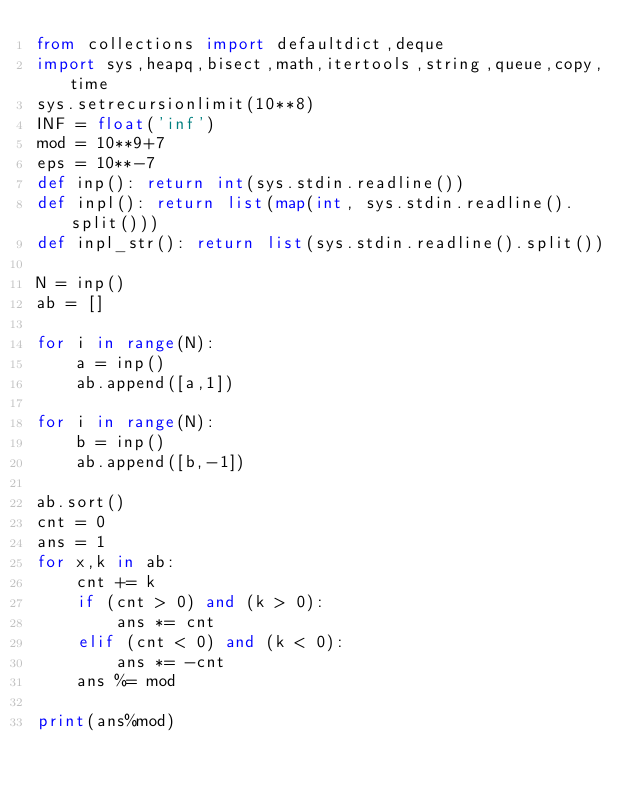Convert code to text. <code><loc_0><loc_0><loc_500><loc_500><_Python_>from collections import defaultdict,deque
import sys,heapq,bisect,math,itertools,string,queue,copy,time
sys.setrecursionlimit(10**8)
INF = float('inf')
mod = 10**9+7
eps = 10**-7
def inp(): return int(sys.stdin.readline())
def inpl(): return list(map(int, sys.stdin.readline().split()))
def inpl_str(): return list(sys.stdin.readline().split())

N = inp()
ab = []

for i in range(N):
    a = inp()
    ab.append([a,1])

for i in range(N):
    b = inp()
    ab.append([b,-1])

ab.sort()
cnt = 0
ans = 1
for x,k in ab:
    cnt += k
    if (cnt > 0) and (k > 0):
        ans *= cnt
    elif (cnt < 0) and (k < 0):
        ans *= -cnt
    ans %= mod
    
print(ans%mod)
</code> 